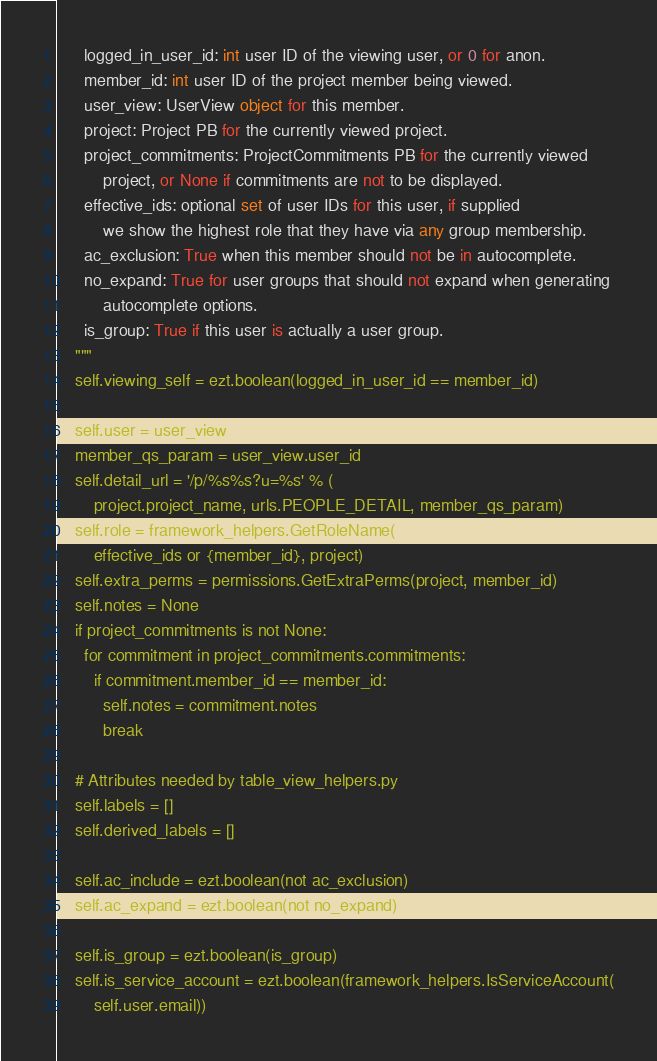Convert code to text. <code><loc_0><loc_0><loc_500><loc_500><_Python_>      logged_in_user_id: int user ID of the viewing user, or 0 for anon.
      member_id: int user ID of the project member being viewed.
      user_view: UserView object for this member.
      project: Project PB for the currently viewed project.
      project_commitments: ProjectCommitments PB for the currently viewed
          project, or None if commitments are not to be displayed.
      effective_ids: optional set of user IDs for this user, if supplied
          we show the highest role that they have via any group membership.
      ac_exclusion: True when this member should not be in autocomplete.
      no_expand: True for user groups that should not expand when generating
          autocomplete options.
      is_group: True if this user is actually a user group.
    """
    self.viewing_self = ezt.boolean(logged_in_user_id == member_id)

    self.user = user_view
    member_qs_param = user_view.user_id
    self.detail_url = '/p/%s%s?u=%s' % (
        project.project_name, urls.PEOPLE_DETAIL, member_qs_param)
    self.role = framework_helpers.GetRoleName(
        effective_ids or {member_id}, project)
    self.extra_perms = permissions.GetExtraPerms(project, member_id)
    self.notes = None
    if project_commitments is not None:
      for commitment in project_commitments.commitments:
        if commitment.member_id == member_id:
          self.notes = commitment.notes
          break

    # Attributes needed by table_view_helpers.py
    self.labels = []
    self.derived_labels = []

    self.ac_include = ezt.boolean(not ac_exclusion)
    self.ac_expand = ezt.boolean(not no_expand)

    self.is_group = ezt.boolean(is_group)
    self.is_service_account = ezt.boolean(framework_helpers.IsServiceAccount(
        self.user.email))
</code> 